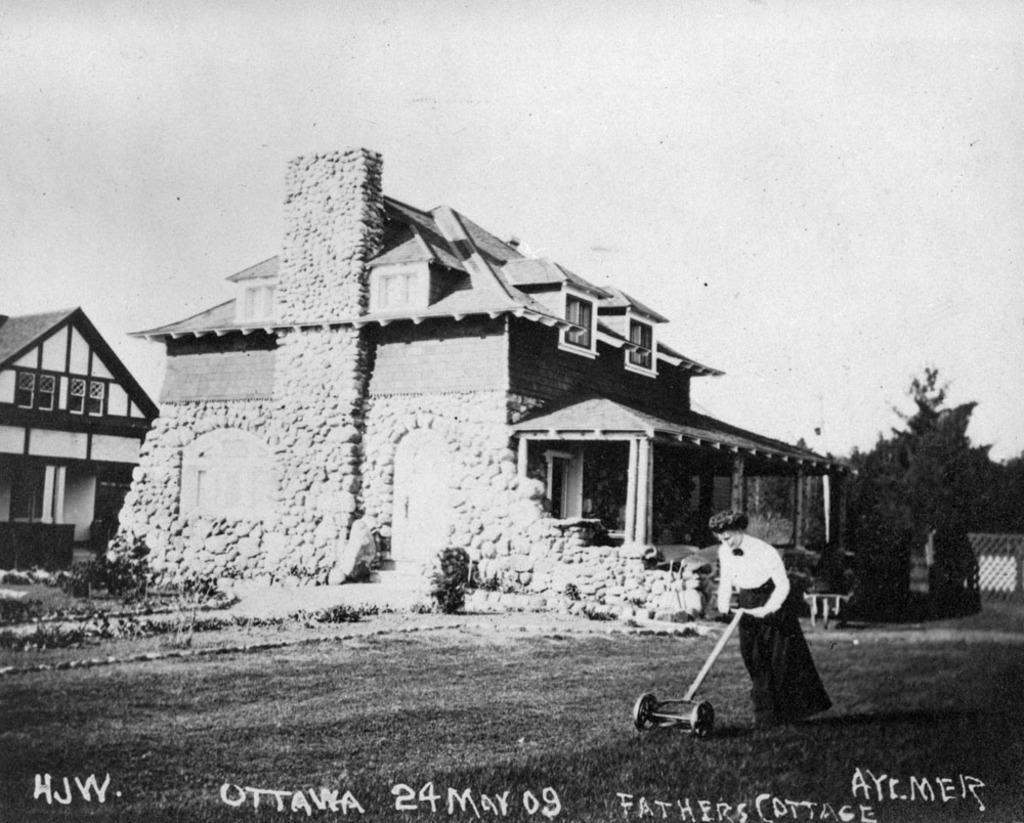Can you describe this image briefly? In this image we can see a black and white picture with some text, there is a woman holding a grass cutter, on the left side of the image there are buildings, trees and sky in the background. 